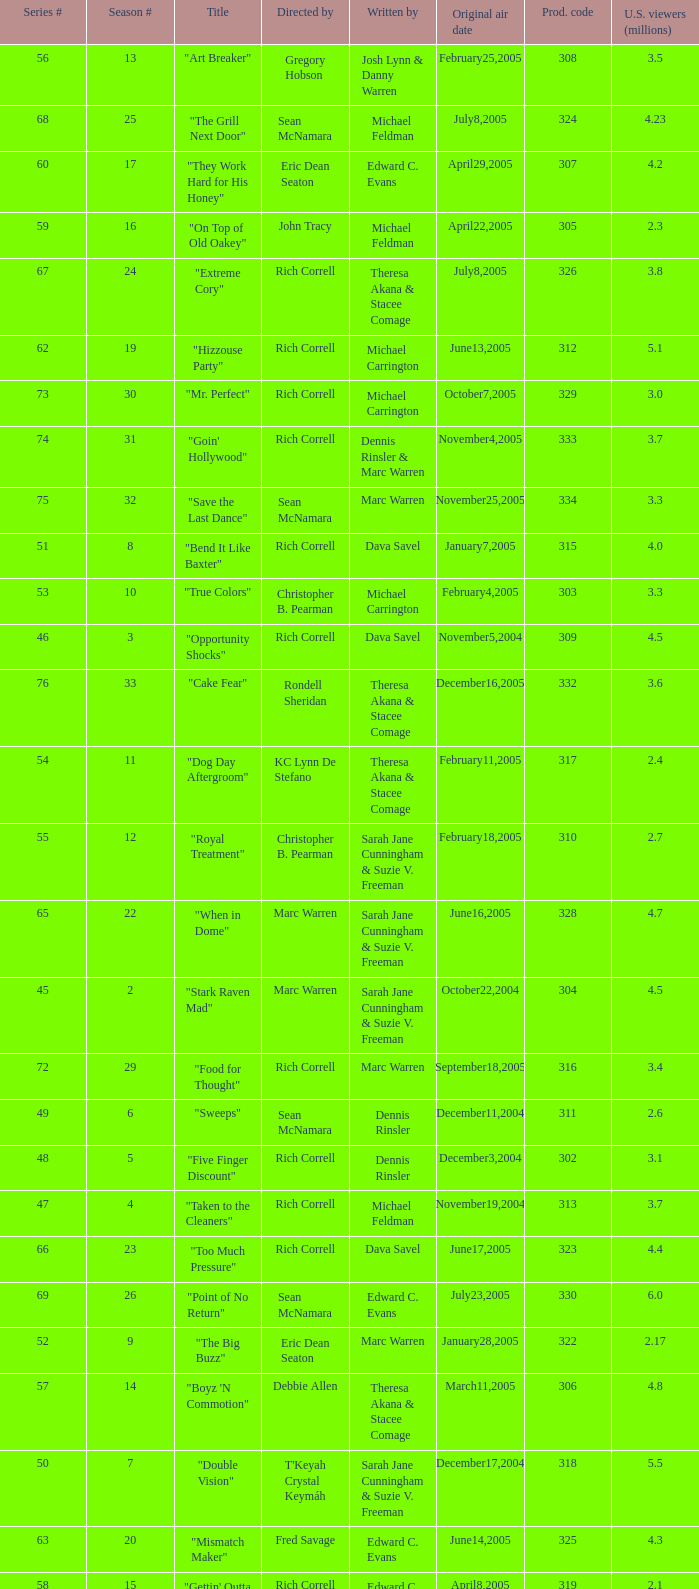What is the title of the episode directed by Rich Correll and written by Dennis Rinsler? "Five Finger Discount". 